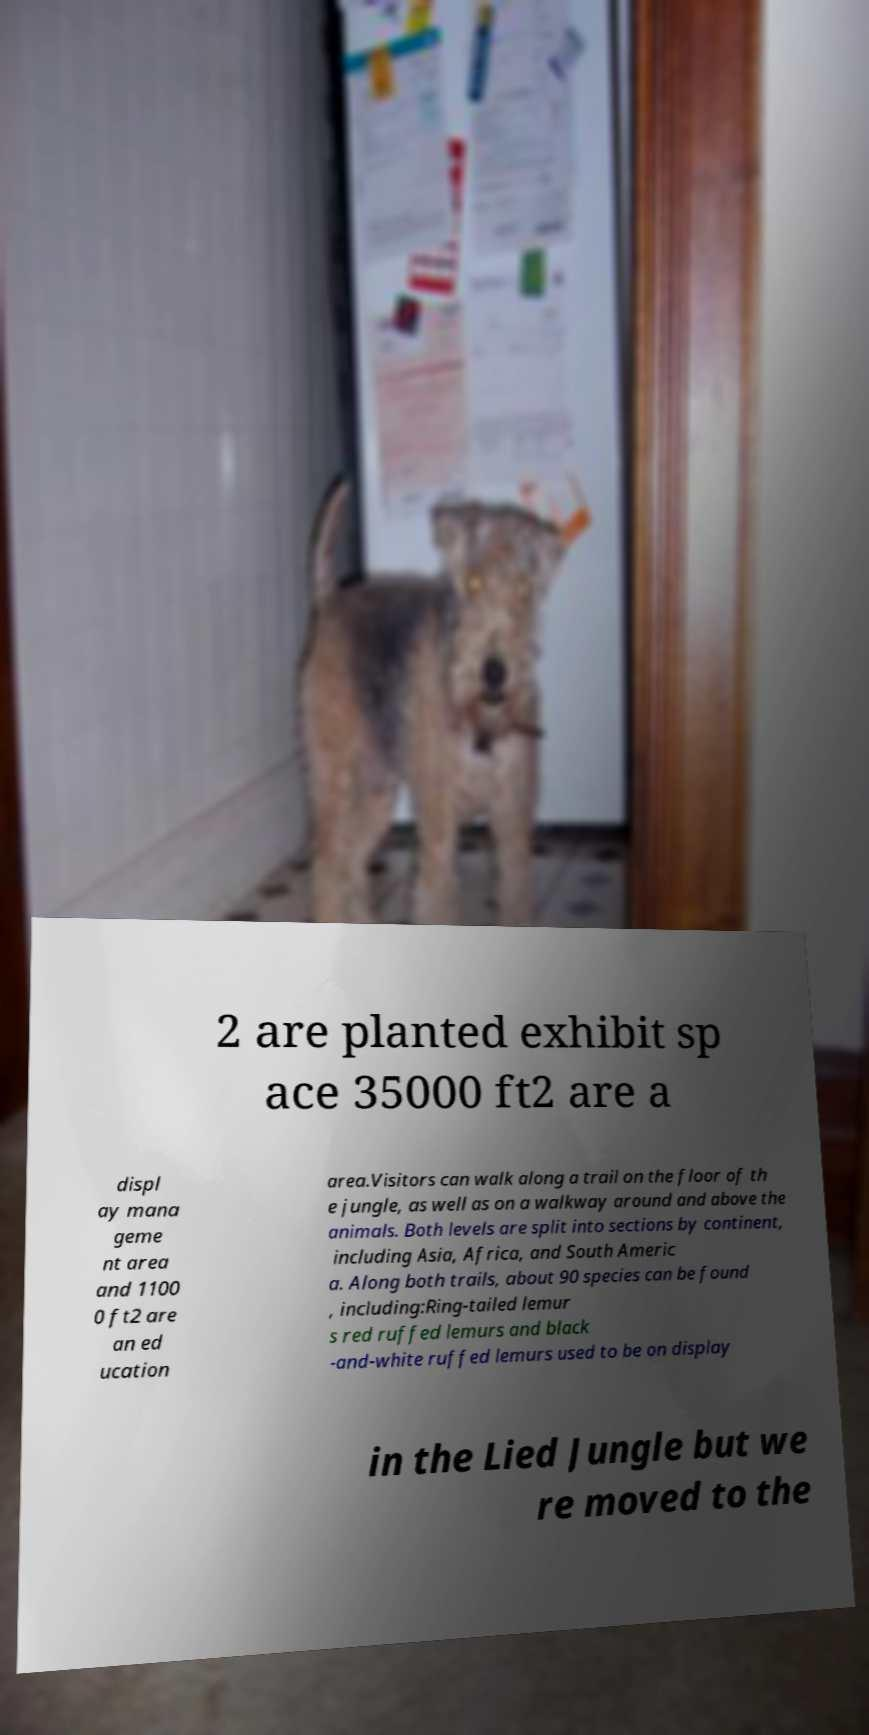Please identify and transcribe the text found in this image. 2 are planted exhibit sp ace 35000 ft2 are a displ ay mana geme nt area and 1100 0 ft2 are an ed ucation area.Visitors can walk along a trail on the floor of th e jungle, as well as on a walkway around and above the animals. Both levels are split into sections by continent, including Asia, Africa, and South Americ a. Along both trails, about 90 species can be found , including:Ring-tailed lemur s red ruffed lemurs and black -and-white ruffed lemurs used to be on display in the Lied Jungle but we re moved to the 